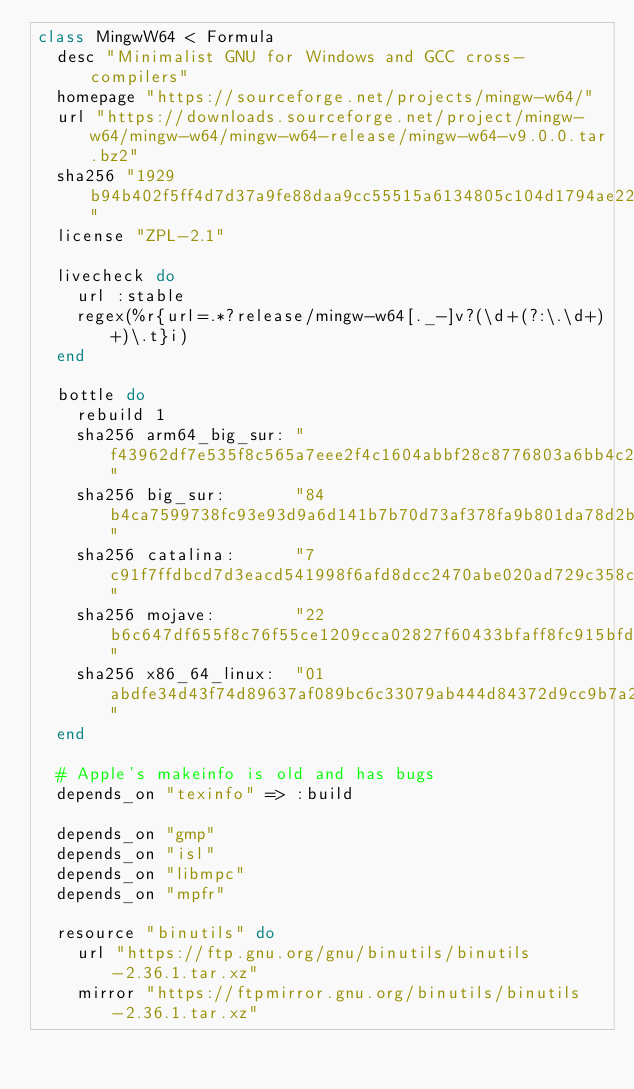<code> <loc_0><loc_0><loc_500><loc_500><_Ruby_>class MingwW64 < Formula
  desc "Minimalist GNU for Windows and GCC cross-compilers"
  homepage "https://sourceforge.net/projects/mingw-w64/"
  url "https://downloads.sourceforge.net/project/mingw-w64/mingw-w64/mingw-w64-release/mingw-w64-v9.0.0.tar.bz2"
  sha256 "1929b94b402f5ff4d7d37a9fe88daa9cc55515a6134805c104d1794ae22a4181"
  license "ZPL-2.1"

  livecheck do
    url :stable
    regex(%r{url=.*?release/mingw-w64[._-]v?(\d+(?:\.\d+)+)\.t}i)
  end

  bottle do
    rebuild 1
    sha256 arm64_big_sur: "f43962df7e535f8c565a7eee2f4c1604abbf28c8776803a6bb4c2e07a39c4a80"
    sha256 big_sur:       "84b4ca7599738fc93e93d9a6d141b7b70d73af378fa9b801da78d2b9d80688e8"
    sha256 catalina:      "7c91f7ffdbcd7d3eacd541998f6afd8dcc2470abe020ad729c358cbac2bed5e6"
    sha256 mojave:        "22b6c647df655f8c76f55ce1209cca02827f60433bfaff8fc915bfd4ed44f31d"
    sha256 x86_64_linux:  "01abdfe34d43f74d89637af089bc6c33079ab444d84372d9cc9b7a22469ef21b"
  end

  # Apple's makeinfo is old and has bugs
  depends_on "texinfo" => :build

  depends_on "gmp"
  depends_on "isl"
  depends_on "libmpc"
  depends_on "mpfr"

  resource "binutils" do
    url "https://ftp.gnu.org/gnu/binutils/binutils-2.36.1.tar.xz"
    mirror "https://ftpmirror.gnu.org/binutils/binutils-2.36.1.tar.xz"</code> 